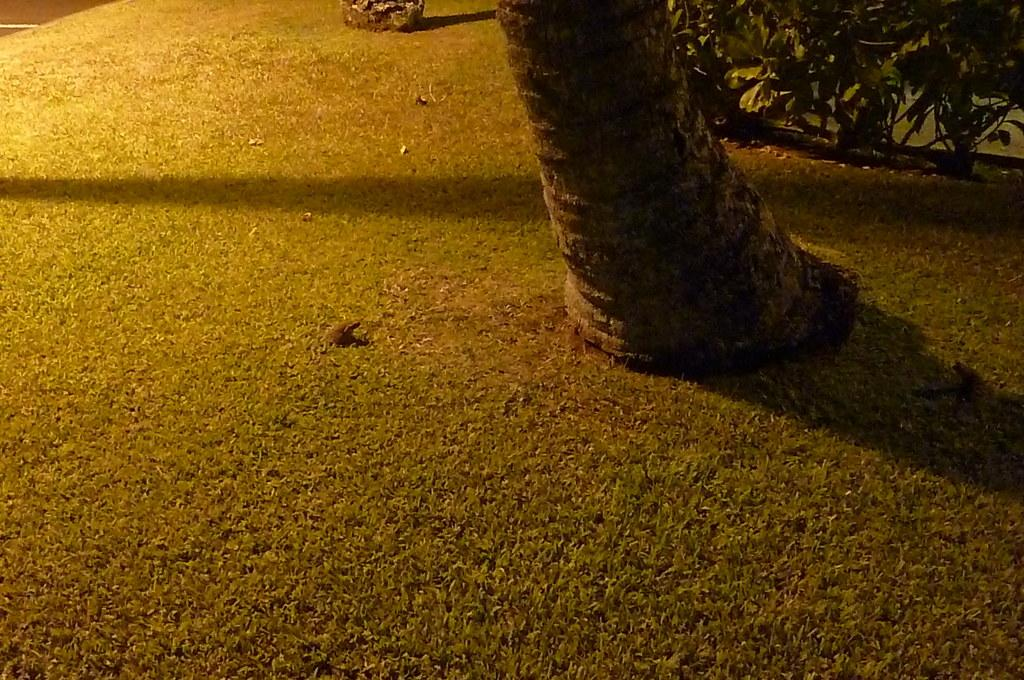What type of surface is visible on the ground in the image? There is grass on the ground in the image. Can you describe any specific features of the grass? There is a stem visible in the image. Where are the plants located in the image? The plants are in the top right of the image. How does the tramp contribute to the respect shown in the image? There is no tramp present in the image, so it is not possible to determine how it might contribute to respect. 